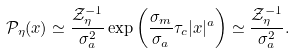Convert formula to latex. <formula><loc_0><loc_0><loc_500><loc_500>\mathcal { P } _ { \eta } ( x ) \simeq \frac { \mathcal { Z } _ { \eta } ^ { - 1 } } { \sigma _ { a } ^ { 2 } } \exp \left ( \frac { \sigma _ { m } } { \sigma _ { a } } \tau _ { c } | x | ^ { a } \right ) \simeq \frac { \mathcal { Z } _ { \eta } ^ { - 1 } } { \sigma _ { a } ^ { 2 } } .</formula> 